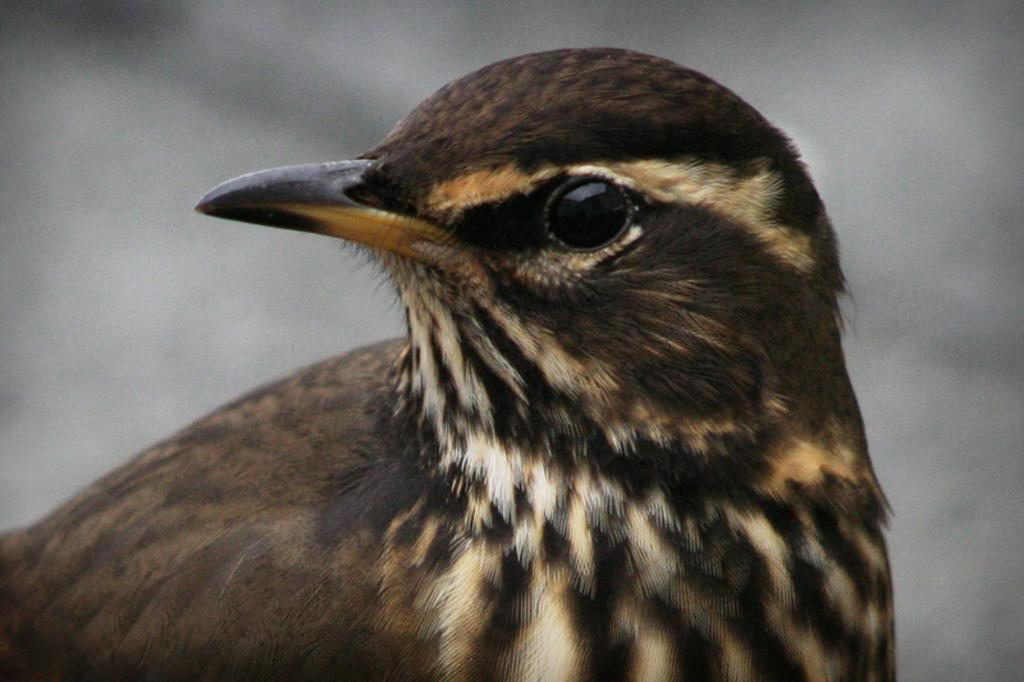What type of animal can be seen in the image? There is a brown bird in the image. Can you describe the background of the image? The background of the image is blurred. What feature is visible in the front of the image? There is a black eye visible in the front of the image. What type of quiver is the bird holding in the image? There is no quiver present in the image; it features a brown bird with a black eye and a blurred background. 